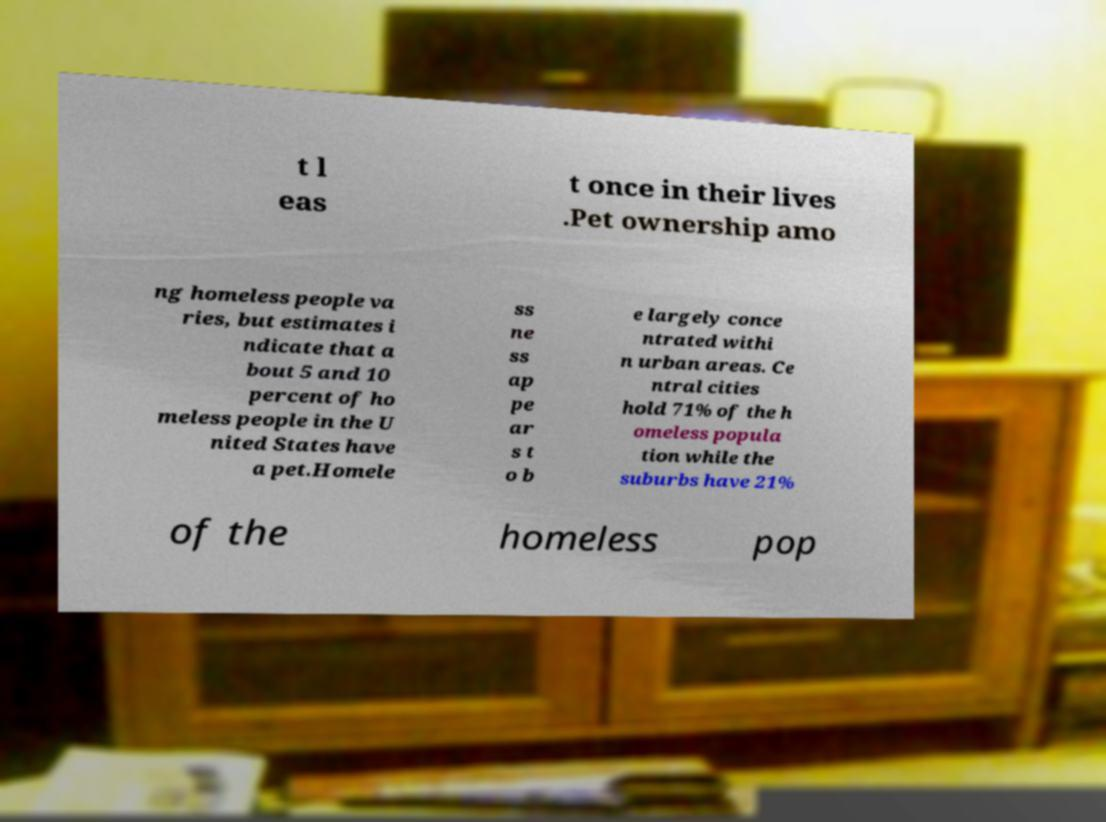Could you assist in decoding the text presented in this image and type it out clearly? t l eas t once in their lives .Pet ownership amo ng homeless people va ries, but estimates i ndicate that a bout 5 and 10 percent of ho meless people in the U nited States have a pet.Homele ss ne ss ap pe ar s t o b e largely conce ntrated withi n urban areas. Ce ntral cities hold 71% of the h omeless popula tion while the suburbs have 21% of the homeless pop 